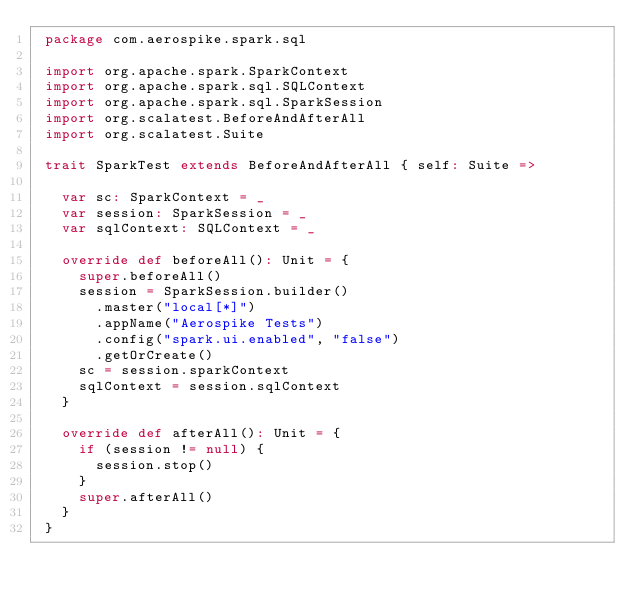Convert code to text. <code><loc_0><loc_0><loc_500><loc_500><_Scala_> package com.aerospike.spark.sql

 import org.apache.spark.SparkContext
 import org.apache.spark.sql.SQLContext
 import org.apache.spark.sql.SparkSession
 import org.scalatest.BeforeAndAfterAll
 import org.scalatest.Suite

 trait SparkTest extends BeforeAndAfterAll { self: Suite =>

   var sc: SparkContext = _
   var session: SparkSession = _
   var sqlContext: SQLContext = _

   override def beforeAll(): Unit = {
     super.beforeAll()
     session = SparkSession.builder()
       .master("local[*]")
       .appName("Aerospike Tests")
       .config("spark.ui.enabled", "false")
       .getOrCreate()
     sc = session.sparkContext
     sqlContext = session.sqlContext
   }

   override def afterAll(): Unit = {
     if (session != null) {
       session.stop()
     }
     super.afterAll()
   }
 }
</code> 